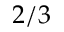<formula> <loc_0><loc_0><loc_500><loc_500>2 / 3</formula> 